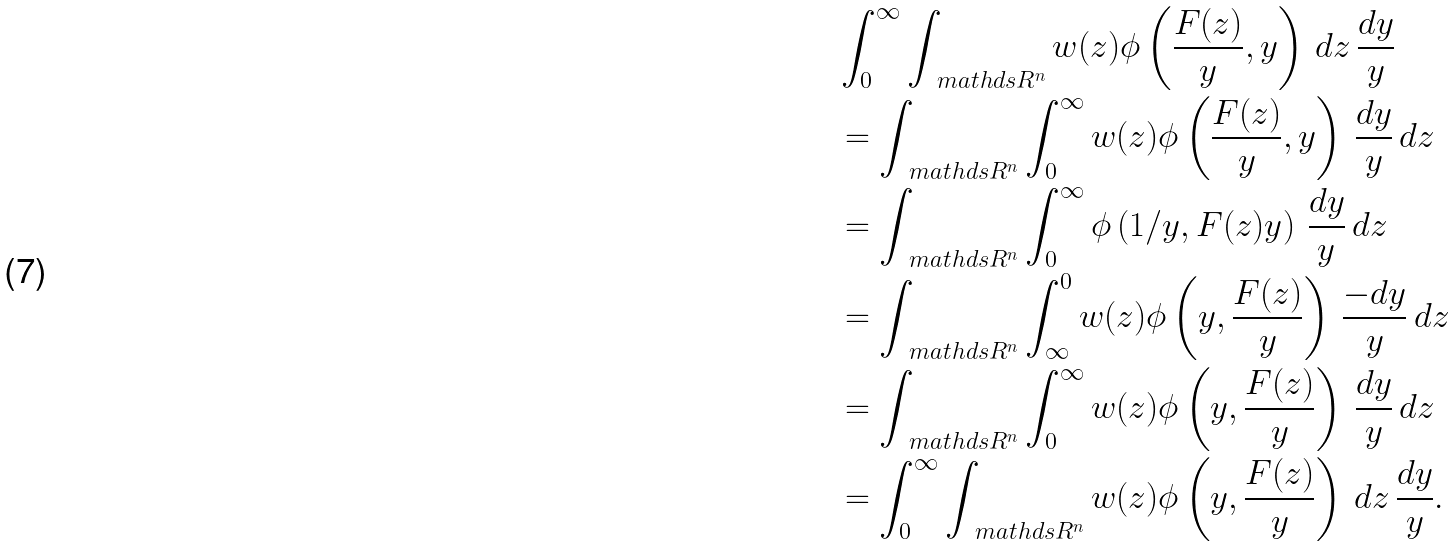Convert formula to latex. <formula><loc_0><loc_0><loc_500><loc_500>& \int _ { 0 } ^ { \infty } \int _ { \ m a t h d s { R } ^ { n } } w ( z ) \phi \left ( \frac { F ( z ) } { y } , y \right ) \, d z \, \frac { d y } { y } \\ & = \int _ { \ m a t h d s { R } ^ { n } } \int _ { 0 } ^ { \infty } w ( z ) \phi \left ( \frac { F ( z ) } { y } , y \right ) \, \frac { d y } { y } \, d z \\ & = \int _ { \ m a t h d s { R } ^ { n } } \int _ { 0 } ^ { \infty } \phi \left ( 1 / y , F ( z ) y \right ) \, \frac { d y } { y } \, d z \\ & = \int _ { \ m a t h d s { R } ^ { n } } \int _ { \infty } ^ { 0 } w ( z ) \phi \left ( y , \frac { F ( z ) } { y } \right ) \, \frac { - d y } { y } \, d z \\ & = \int _ { \ m a t h d s { R } ^ { n } } \int _ { 0 } ^ { \infty } w ( z ) \phi \left ( y , \frac { F ( z ) } { y } \right ) \, \frac { d y } { y } \, d z \\ & = \int _ { 0 } ^ { \infty } \int _ { \ m a t h d s { R } ^ { n } } w ( z ) \phi \left ( y , \frac { F ( z ) } { y } \right ) \, d z \, \frac { d y } { y } .</formula> 